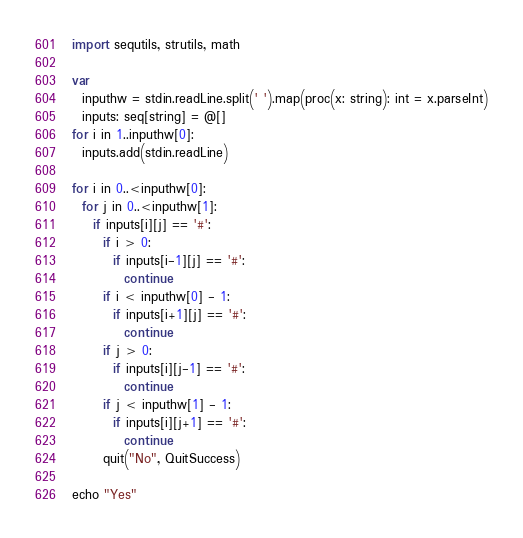<code> <loc_0><loc_0><loc_500><loc_500><_Nim_>import sequtils, strutils, math

var
  inputhw = stdin.readLine.split(' ').map(proc(x: string): int = x.parseInt)
  inputs: seq[string] = @[]
for i in 1..inputhw[0]:
  inputs.add(stdin.readLine)

for i in 0..<inputhw[0]:
  for j in 0..<inputhw[1]:
    if inputs[i][j] == '#':
      if i > 0:
        if inputs[i-1][j] == '#':
          continue
      if i < inputhw[0] - 1:
        if inputs[i+1][j] == '#':
          continue
      if j > 0:
        if inputs[i][j-1] == '#':
          continue
      if j < inputhw[1] - 1:
        if inputs[i][j+1] == '#':
          continue
      quit("No", QuitSuccess)

echo "Yes"</code> 